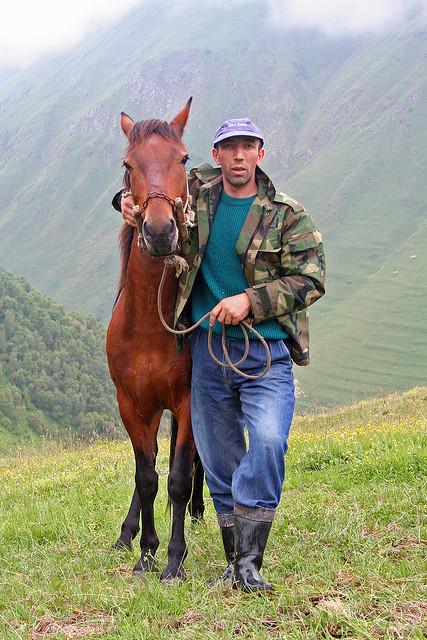Is this his horse?
Write a very short answer. Yes. Is the man tall?
Concise answer only. Yes. Is this man in a uniform?
Write a very short answer. No. Is the man wearing a cowboy hat?
Answer briefly. No. How many people are present?
Be succinct. 1. What type of hat is this person wearing?
Answer briefly. Baseball cap. 